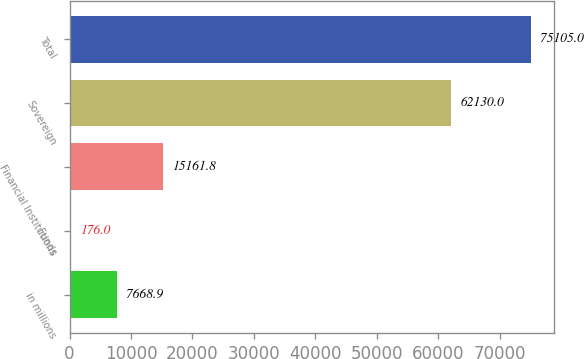Convert chart. <chart><loc_0><loc_0><loc_500><loc_500><bar_chart><fcel>in millions<fcel>Funds<fcel>Financial Institutions<fcel>Sovereign<fcel>Total<nl><fcel>7668.9<fcel>176<fcel>15161.8<fcel>62130<fcel>75105<nl></chart> 